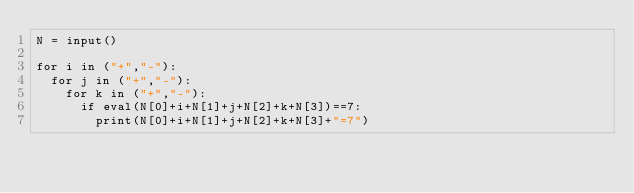<code> <loc_0><loc_0><loc_500><loc_500><_Python_>N = input()

for i in ("+","-"):
  for j in ("+","-"):
    for k in ("+","-"):
      if eval(N[0]+i+N[1]+j+N[2]+k+N[3])==7:
        print(N[0]+i+N[1]+j+N[2]+k+N[3]+"=7")</code> 